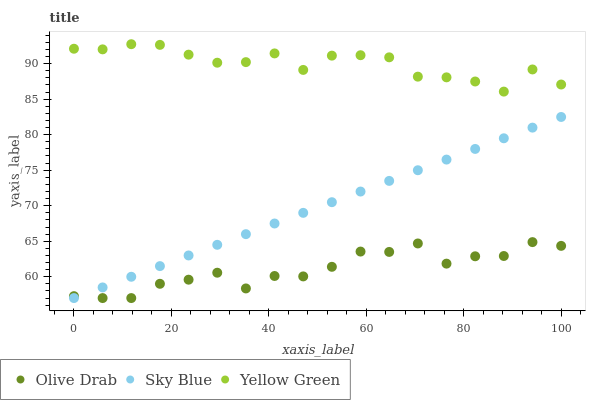Does Olive Drab have the minimum area under the curve?
Answer yes or no. Yes. Does Yellow Green have the maximum area under the curve?
Answer yes or no. Yes. Does Yellow Green have the minimum area under the curve?
Answer yes or no. No. Does Olive Drab have the maximum area under the curve?
Answer yes or no. No. Is Sky Blue the smoothest?
Answer yes or no. Yes. Is Olive Drab the roughest?
Answer yes or no. Yes. Is Yellow Green the smoothest?
Answer yes or no. No. Is Yellow Green the roughest?
Answer yes or no. No. Does Sky Blue have the lowest value?
Answer yes or no. Yes. Does Yellow Green have the lowest value?
Answer yes or no. No. Does Yellow Green have the highest value?
Answer yes or no. Yes. Does Olive Drab have the highest value?
Answer yes or no. No. Is Olive Drab less than Yellow Green?
Answer yes or no. Yes. Is Yellow Green greater than Sky Blue?
Answer yes or no. Yes. Does Sky Blue intersect Olive Drab?
Answer yes or no. Yes. Is Sky Blue less than Olive Drab?
Answer yes or no. No. Is Sky Blue greater than Olive Drab?
Answer yes or no. No. Does Olive Drab intersect Yellow Green?
Answer yes or no. No. 